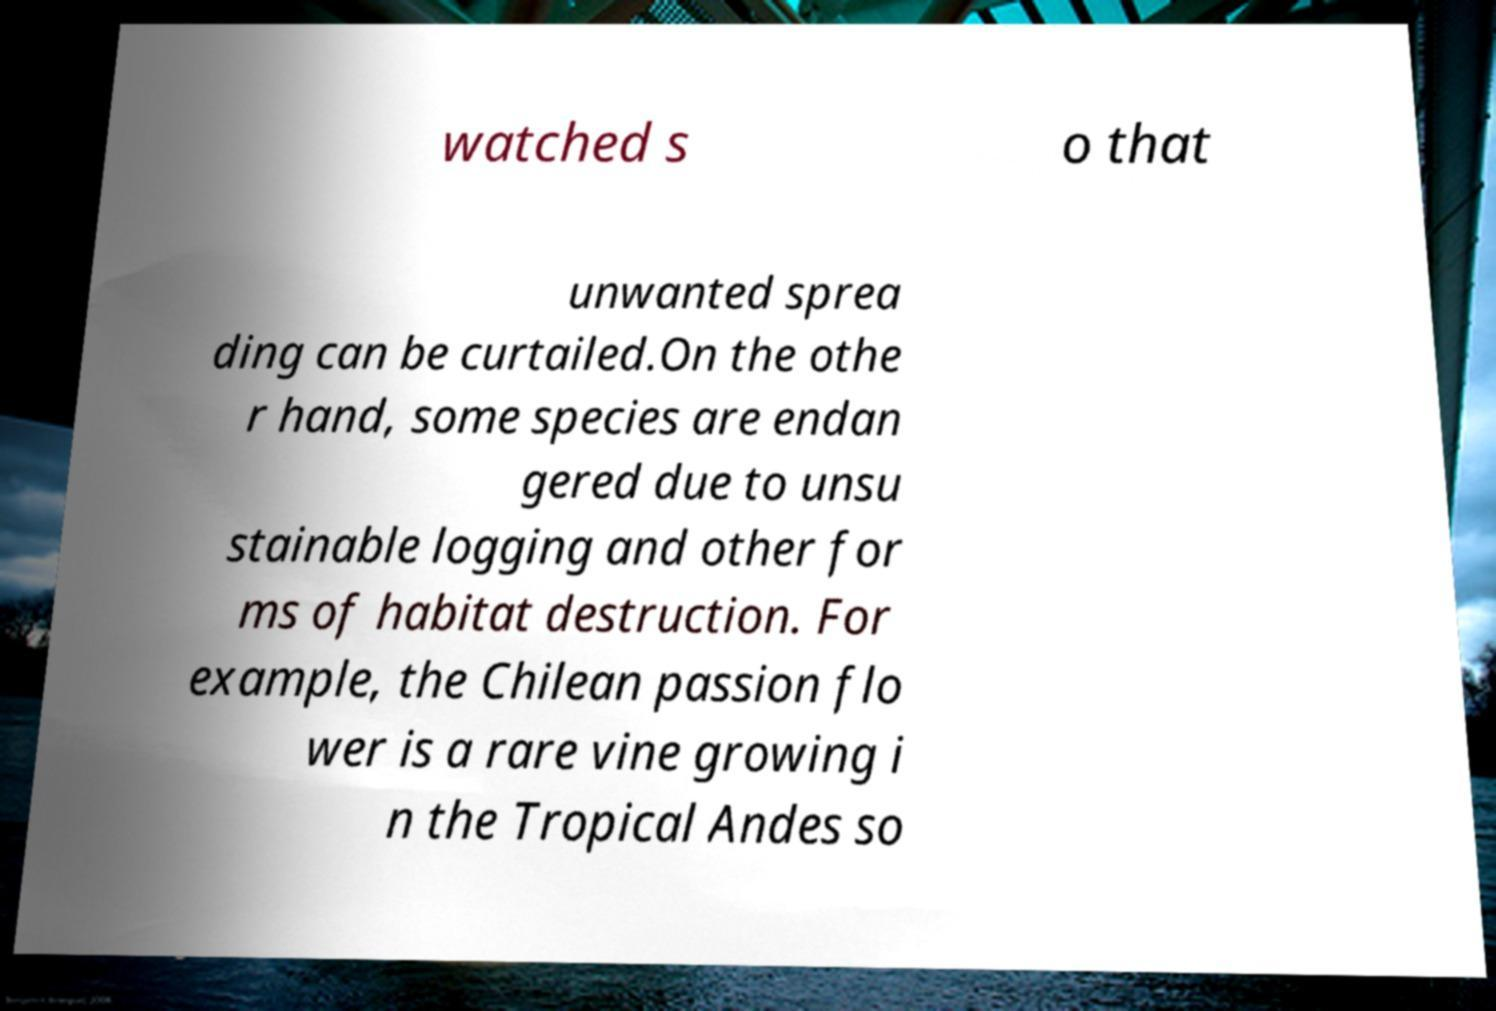Could you extract and type out the text from this image? watched s o that unwanted sprea ding can be curtailed.On the othe r hand, some species are endan gered due to unsu stainable logging and other for ms of habitat destruction. For example, the Chilean passion flo wer is a rare vine growing i n the Tropical Andes so 